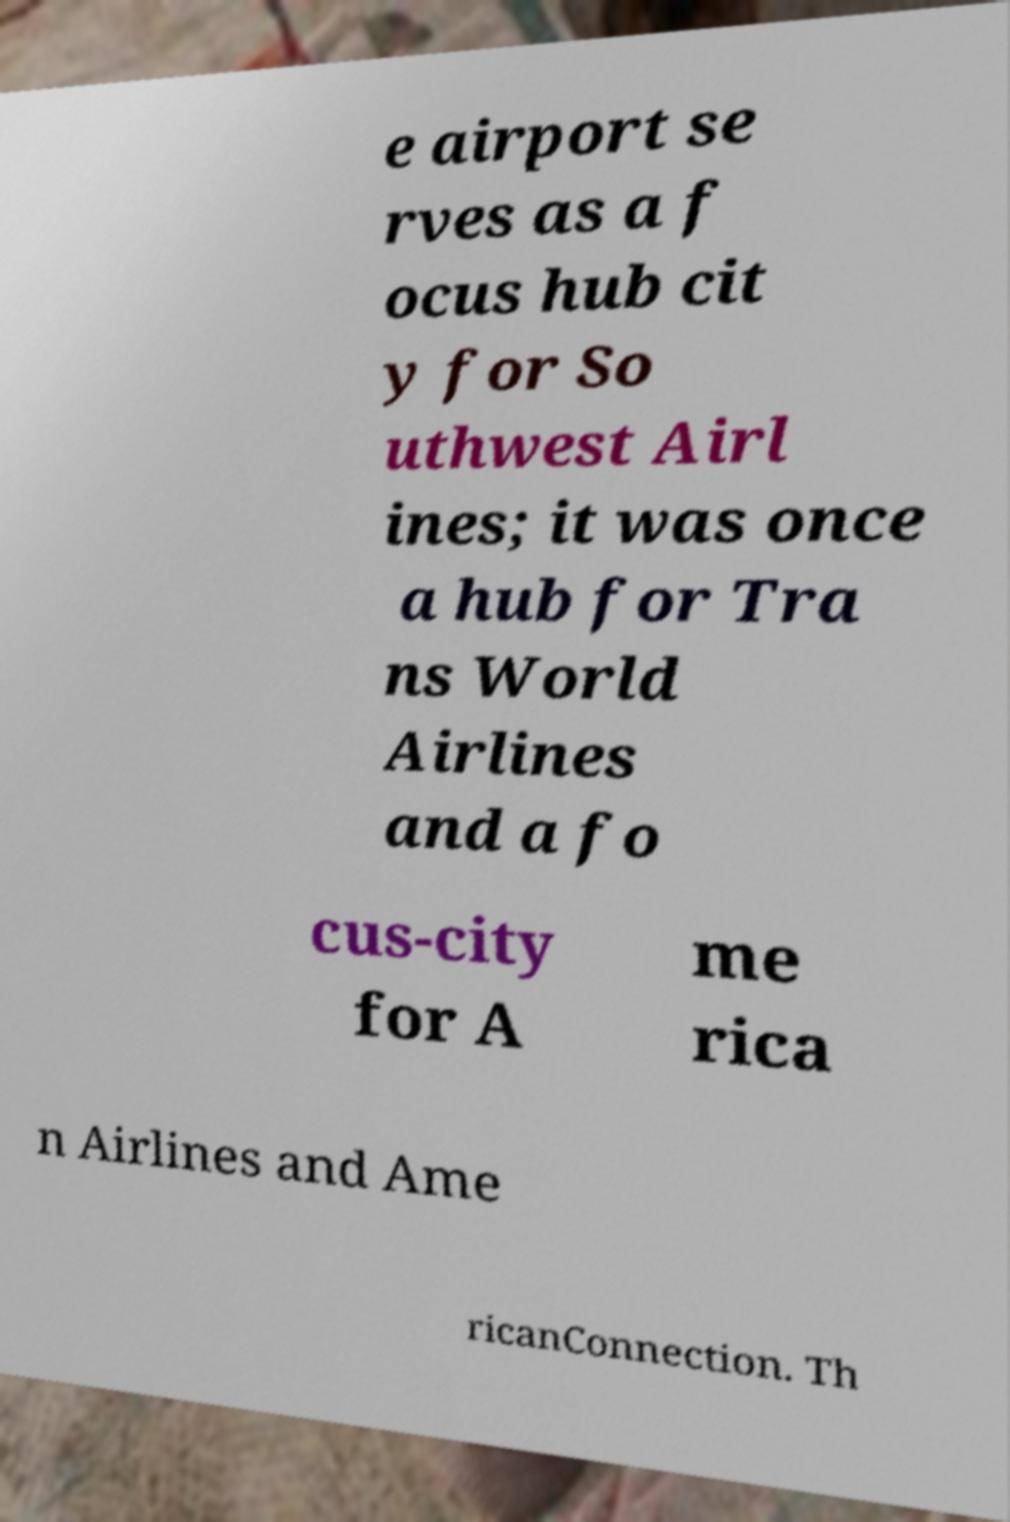Could you assist in decoding the text presented in this image and type it out clearly? e airport se rves as a f ocus hub cit y for So uthwest Airl ines; it was once a hub for Tra ns World Airlines and a fo cus-city for A me rica n Airlines and Ame ricanConnection. Th 